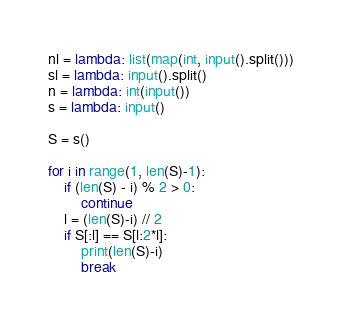Convert code to text. <code><loc_0><loc_0><loc_500><loc_500><_Python_>nl = lambda: list(map(int, input().split()))
sl = lambda: input().split()
n = lambda: int(input())
s = lambda: input()

S = s()

for i in range(1, len(S)-1):
    if (len(S) - i) % 2 > 0:
        continue
    l = (len(S)-i) // 2
    if S[:l] == S[l:2*l]:
        print(len(S)-i)
        break
</code> 